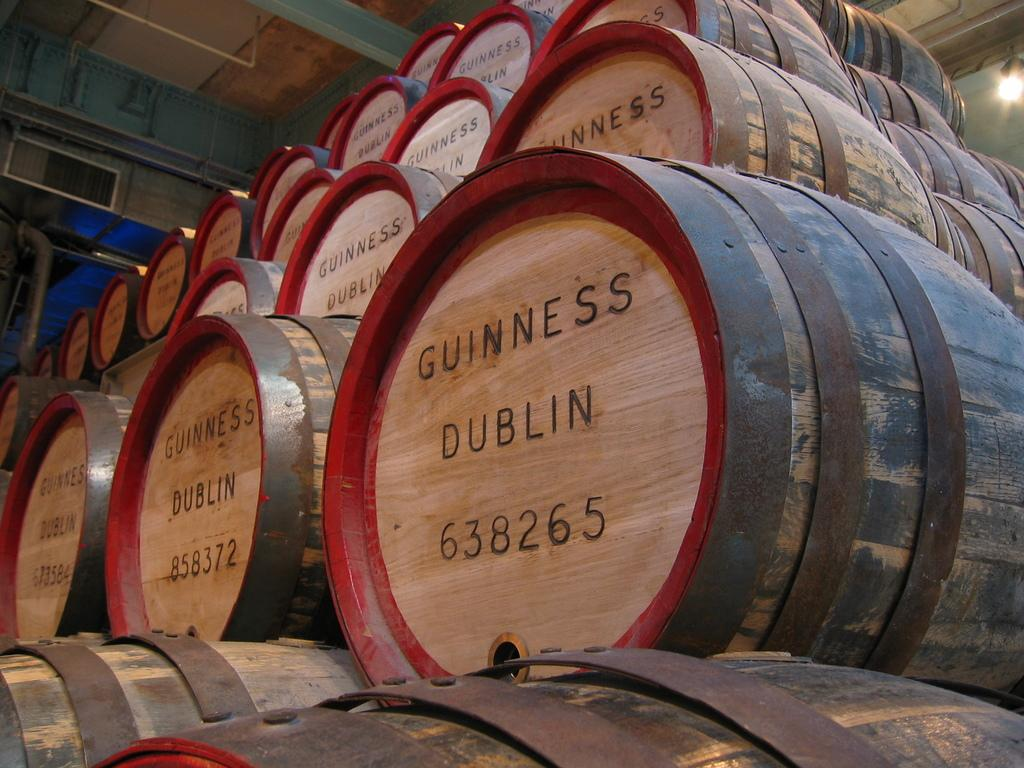What objects in the image? There are barrels in the image. What else can be seen in the background of the image? There is a light in the background of the image. What type of grass is growing around the barrels in the image? There is no grass visible in the image; it only features barrels and a light in the background. 